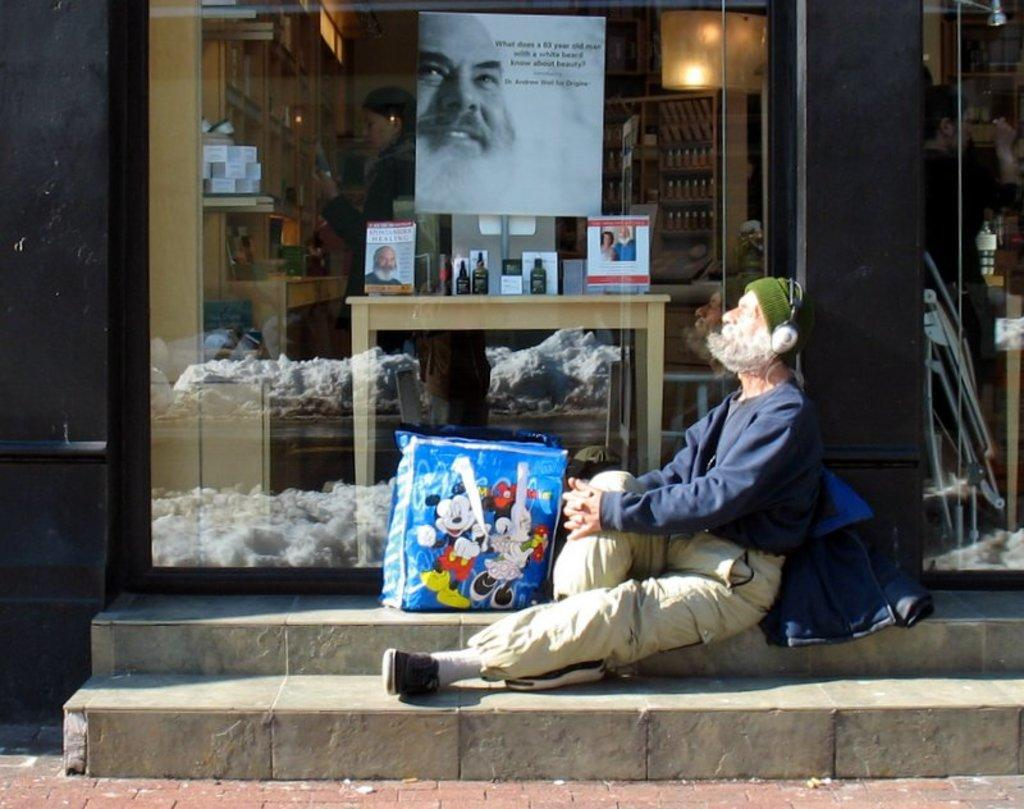Who is the main subject in the image? There is an old man in the image. What is the old man wearing? The old man is wearing a navy blue sweatshirt and jeans. Where is the old man sitting? The old man is sitting on steps. What is the location of the steps? The steps are in front of a store. What type of store is it? The store has books and bottles inside it. How are the books and bottles arranged in the store? The books and bottles are on a table and on racks. Can you see the old man's fang in the image? There is no mention of a fang in the image, and it is not a characteristic of humans. 